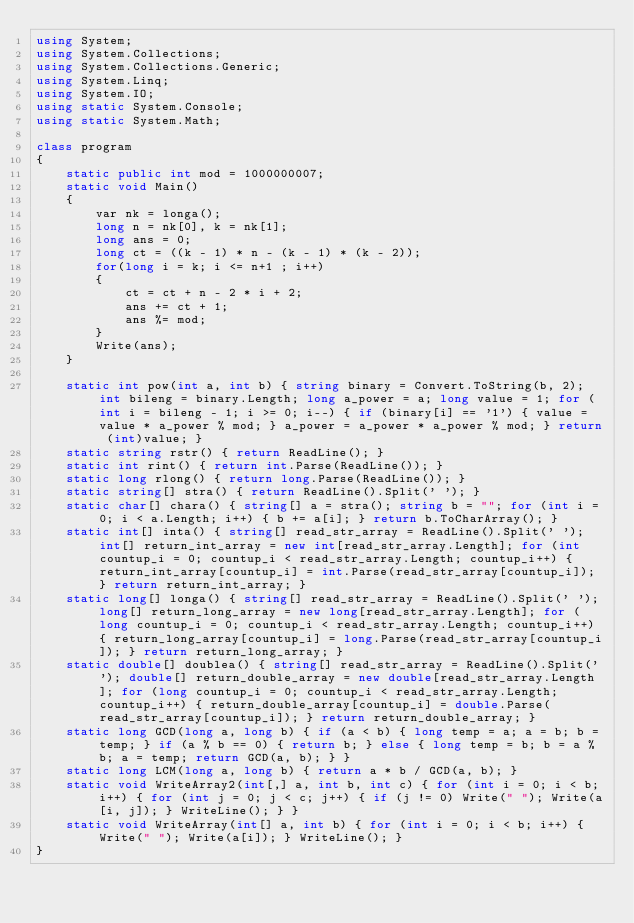Convert code to text. <code><loc_0><loc_0><loc_500><loc_500><_C#_>using System;
using System.Collections;
using System.Collections.Generic;
using System.Linq;
using System.IO;
using static System.Console;
using static System.Math;

class program
{
    static public int mod = 1000000007;
    static void Main()
    {
        var nk = longa();
        long n = nk[0], k = nk[1];
        long ans = 0;
        long ct = ((k - 1) * n - (k - 1) * (k - 2));
        for(long i = k; i <= n+1 ; i++)
        {            
            ct = ct + n - 2 * i + 2;
            ans += ct + 1;
            ans %= mod;
        }
        Write(ans);
    }

    static int pow(int a, int b) { string binary = Convert.ToString(b, 2); int bileng = binary.Length; long a_power = a; long value = 1; for (int i = bileng - 1; i >= 0; i--) { if (binary[i] == '1') { value = value * a_power % mod; } a_power = a_power * a_power % mod; } return (int)value; }
    static string rstr() { return ReadLine(); }
    static int rint() { return int.Parse(ReadLine()); }
    static long rlong() { return long.Parse(ReadLine()); }
    static string[] stra() { return ReadLine().Split(' '); }
    static char[] chara() { string[] a = stra(); string b = ""; for (int i = 0; i < a.Length; i++) { b += a[i]; } return b.ToCharArray(); }
    static int[] inta() { string[] read_str_array = ReadLine().Split(' '); int[] return_int_array = new int[read_str_array.Length]; for (int countup_i = 0; countup_i < read_str_array.Length; countup_i++) { return_int_array[countup_i] = int.Parse(read_str_array[countup_i]); } return return_int_array; }
    static long[] longa() { string[] read_str_array = ReadLine().Split(' '); long[] return_long_array = new long[read_str_array.Length]; for (long countup_i = 0; countup_i < read_str_array.Length; countup_i++) { return_long_array[countup_i] = long.Parse(read_str_array[countup_i]); } return return_long_array; }
    static double[] doublea() { string[] read_str_array = ReadLine().Split(' '); double[] return_double_array = new double[read_str_array.Length]; for (long countup_i = 0; countup_i < read_str_array.Length; countup_i++) { return_double_array[countup_i] = double.Parse(read_str_array[countup_i]); } return return_double_array; }
    static long GCD(long a, long b) { if (a < b) { long temp = a; a = b; b = temp; } if (a % b == 0) { return b; } else { long temp = b; b = a % b; a = temp; return GCD(a, b); } }
    static long LCM(long a, long b) { return a * b / GCD(a, b); }
    static void WriteArray2(int[,] a, int b, int c) { for (int i = 0; i < b; i++) { for (int j = 0; j < c; j++) { if (j != 0) Write(" "); Write(a[i, j]); } WriteLine(); } }
    static void WriteArray(int[] a, int b) { for (int i = 0; i < b; i++) { Write(" "); Write(a[i]); } WriteLine(); }
}
</code> 